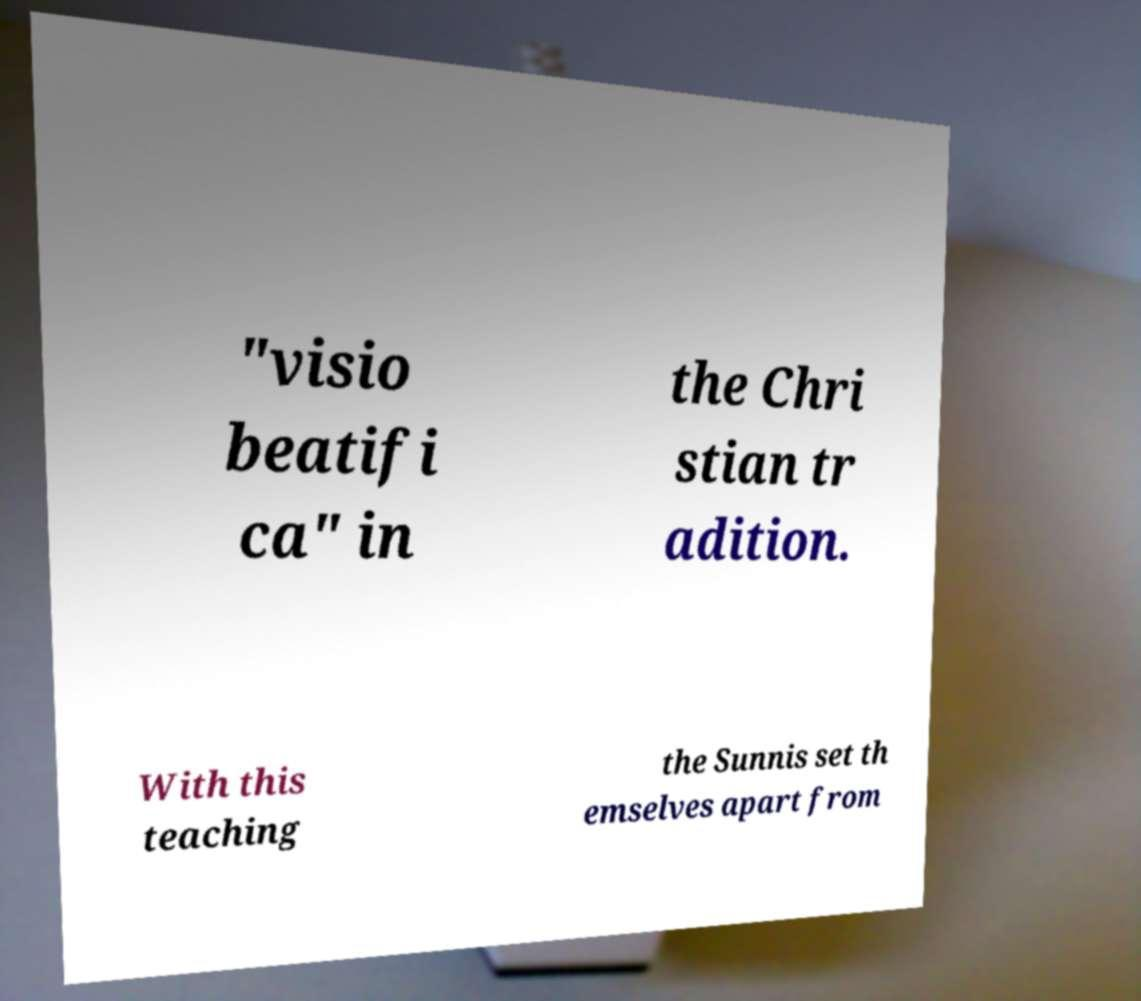There's text embedded in this image that I need extracted. Can you transcribe it verbatim? "visio beatifi ca" in the Chri stian tr adition. With this teaching the Sunnis set th emselves apart from 